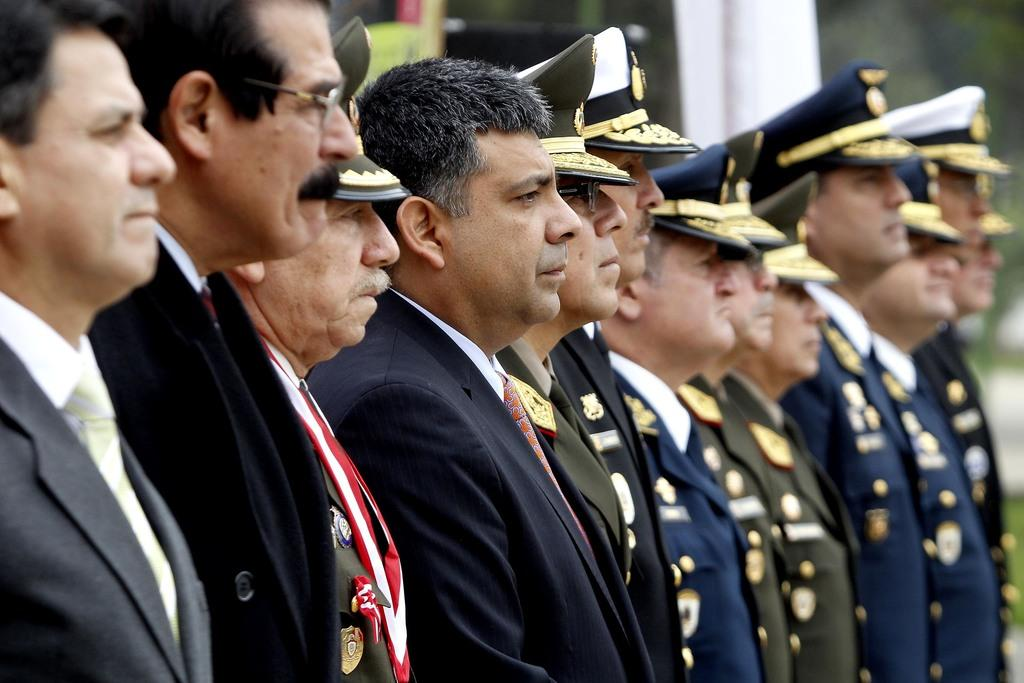How many people are present in the image? There are many people in the image. What accessories can be seen on some of the people? Some people are wearing caps, glasses (specs), and badges. Can you describe the background of the image? The background of the image is blurry. What type of wood can be seen in the image? There is no wood present in the image. How is the hose being used in the image? There is no hose present in the image. 